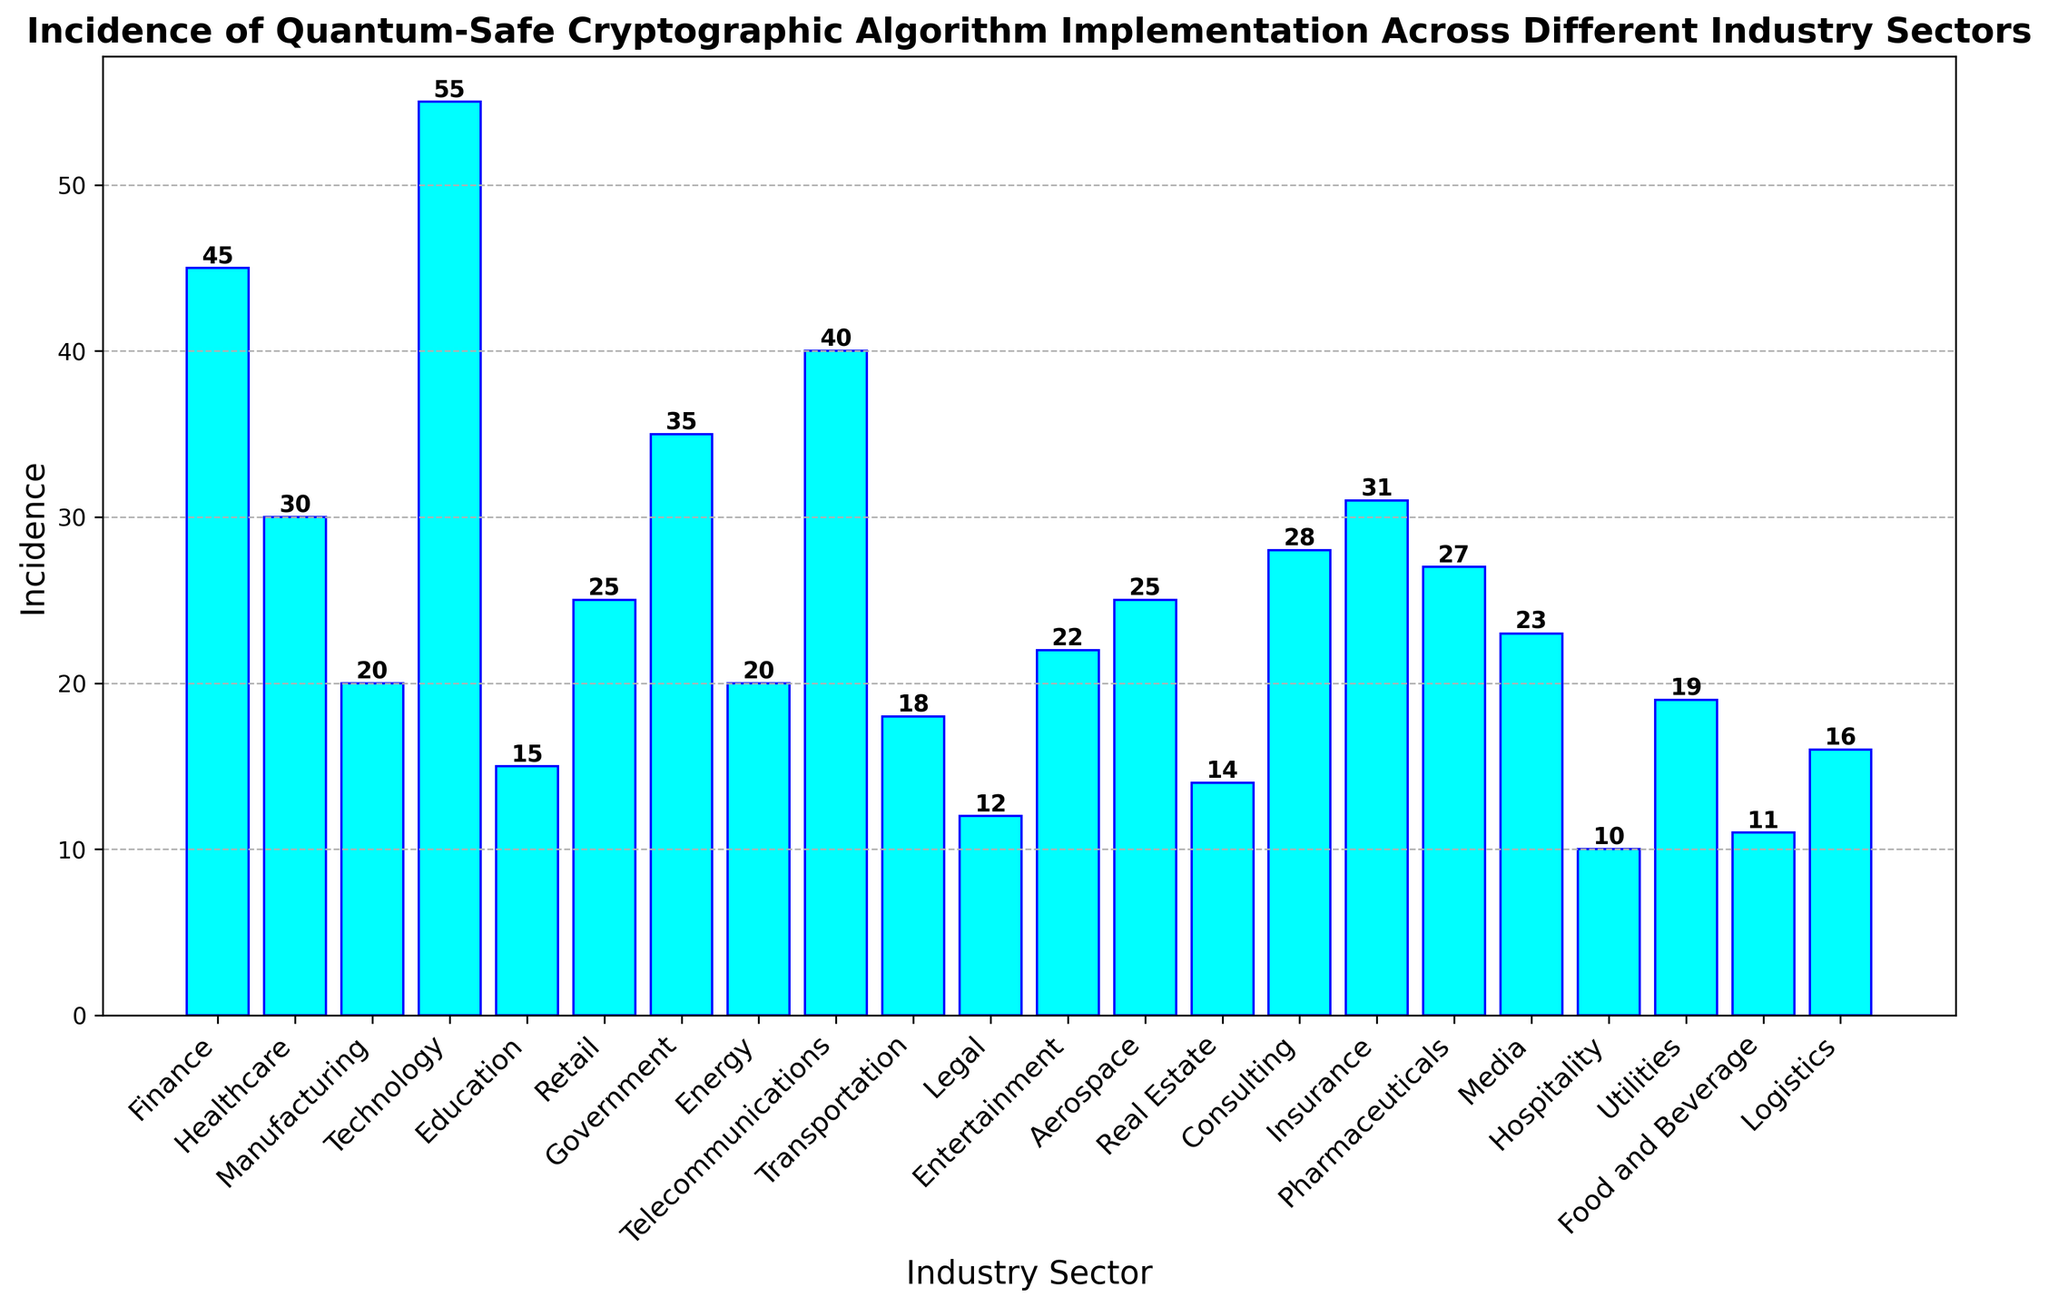Which industry sector has the highest incidence of quantum-safe cryptographic algorithm implementation? The Technology sector has the highest bar on the histogram, indicating it has the greatest number of incidences.
Answer: Technology What's the total incidence of quantum-safe cryptographic algorithm implementation in the Finance, Healthcare, and Government sectors combined? The incidences are Finance: 45, Healthcare: 30, Government: 35. Adding them up, 45 + 30 + 35 = 110.
Answer: 110 Which industry sector has the lowest incidence of quantum-safe cryptographic algorithm implementation? The Hospitality sector has the shortest bar on the histogram, indicating it has the smallest number of incidences.
Answer: Hospitality Compare the incidence of the Technology sector to the Telecommunications sector. How many more incidences does the Technology sector have? The incidences are Technology: 55, Telecommunications: 40. The difference is 55 - 40 = 15.
Answer: 15 What is the average incidence of quantum-safe cryptographic algorithm implementation across all industry sectors? Sum all incidences (45+30+20+55+15+25+35+20+40+18+12+22+25+14+28+31+27+23+10+19+11+16) which equals 541. Divide by the number of sectors (23). 541 / 23 = 23.52.
Answer: 23.52 Are there more sectors with incidences higher than or equal to 30 or incidences lower than 30? Sectors with ≥30: Finance, Healthcare, Technology, Government, Telecommunications, Insurance. Sectors with <30: Manufacturing, Education, Retail, Energy, Transportation, Legal, Entertainment, Aerospace, Real Estate, Consulting, Pharmaceuticals, Media, Hospitality, Utilities, Food, Logistics. Comparing counts: 6 sectors ≥30 vs. 17 sectors <30.
Answer: Lower than 30 What is the combined incidence of the top three sectors? The top three sectors by incidence are Technology (55), Finance (45), and Telecommunications (40). Adding them up, 55 + 45 + 40 = 140.
Answer: 140 Which industries have an incidence value closest to the overall average incidence of 23.52? Closest values to 23.52 are Media (23) and Entertainment (22).
Answer: Media and Entertainment What is the difference between the highest and the lowest incidence values? The highest incidence is in the Technology sector (55), and the lowest is in the Hospitality sector (10). The difference is 55 - 10 = 45.
Answer: 45 